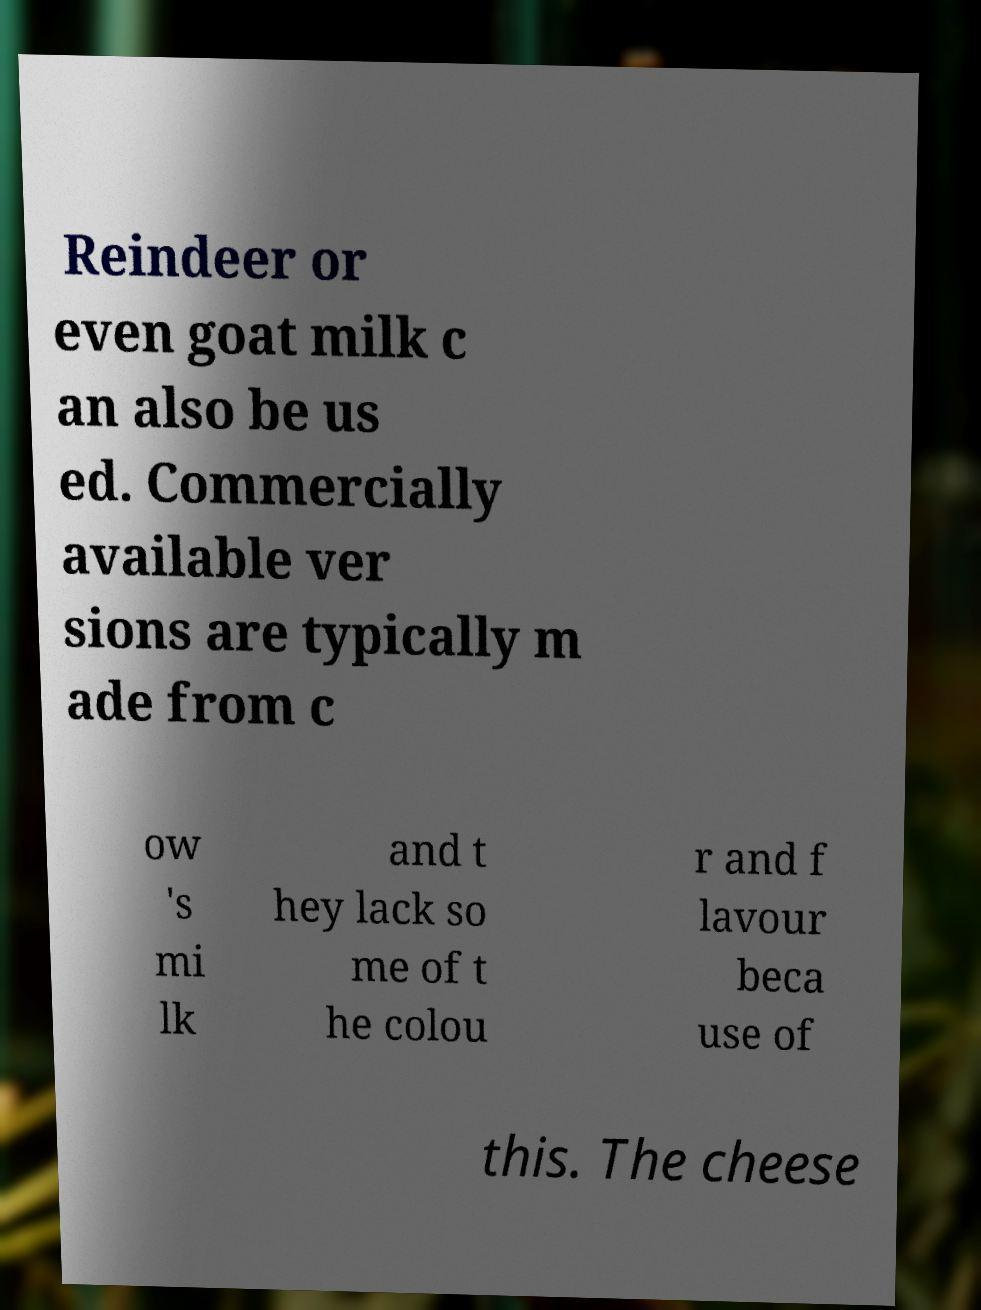Could you assist in decoding the text presented in this image and type it out clearly? Reindeer or even goat milk c an also be us ed. Commercially available ver sions are typically m ade from c ow 's mi lk and t hey lack so me of t he colou r and f lavour beca use of this. The cheese 